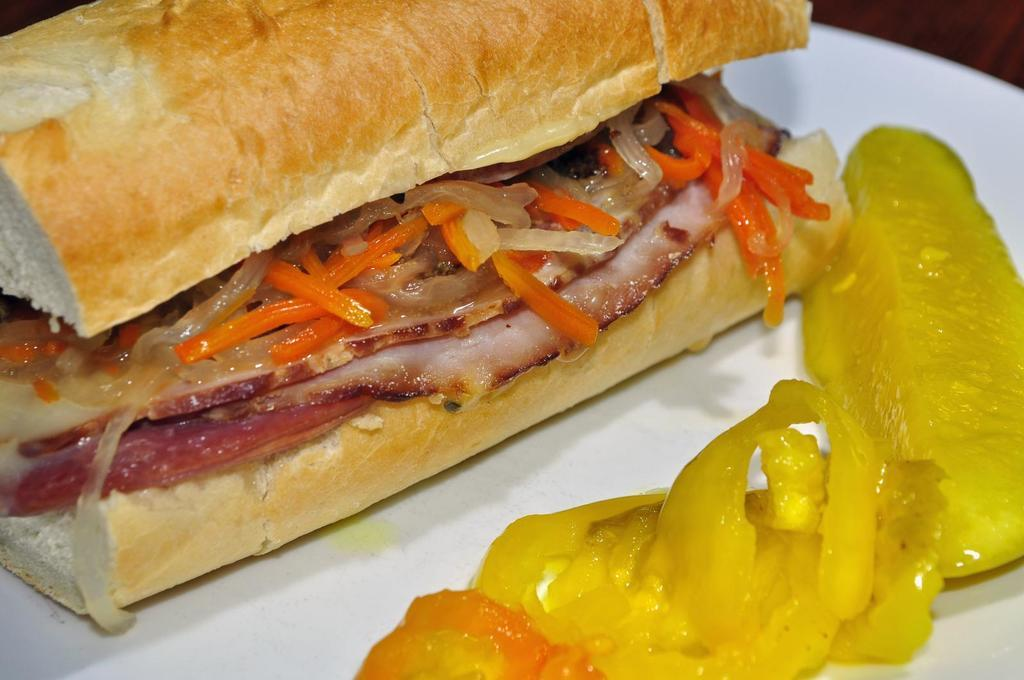What is on the plate that is visible in the image? There is a white plate in the image. What is on top of the plate? The plate has food on it. Can you describe the colors of the food on the plate? The food has various colors, including brown, yellow, cream, red, and orange. What time of day is the spy observing the plate in the image? There is no spy present in the image, and therefore no observation of the plate can be made. 